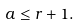Convert formula to latex. <formula><loc_0><loc_0><loc_500><loc_500>a \leq r + 1 .</formula> 